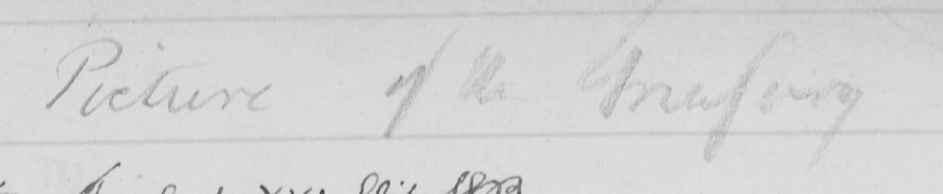What is written in this line of handwriting? Picture of the Treasury 